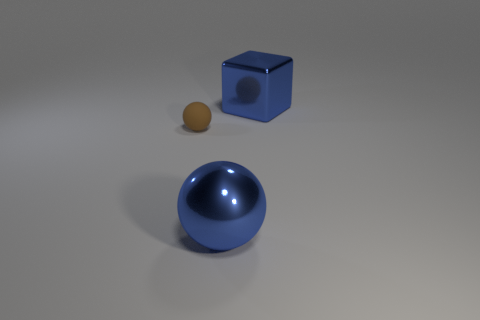What number of large shiny balls are the same color as the block?
Give a very brief answer. 1. Is the color of the sphere on the right side of the matte object the same as the block?
Offer a very short reply. Yes. How big is the object that is behind the big blue shiny ball and to the left of the blue block?
Your answer should be very brief. Small. Are there any red rubber things?
Ensure brevity in your answer.  No. What number of other objects are there of the same size as the block?
Your answer should be very brief. 1. Does the metal thing behind the brown thing have the same color as the large metal thing in front of the tiny brown rubber thing?
Offer a very short reply. Yes. Are the ball that is in front of the tiny matte ball and the sphere that is behind the big ball made of the same material?
Your answer should be compact. No. How many shiny objects are small brown objects or small blue cubes?
Give a very brief answer. 0. What material is the small thing to the left of the big blue object right of the blue shiny object that is in front of the brown sphere made of?
Provide a short and direct response. Rubber. There is a big blue shiny object that is left of the large metallic cube; is it the same shape as the thing left of the shiny sphere?
Provide a short and direct response. Yes. 